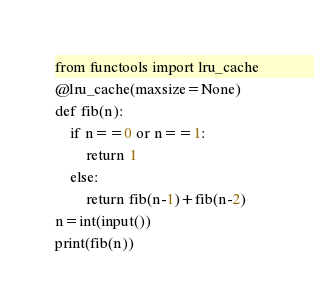<code> <loc_0><loc_0><loc_500><loc_500><_Python_>from functools import lru_cache
@lru_cache(maxsize=None)
def fib(n):
    if n==0 or n==1:
        return 1
    else:
        return fib(n-1)+fib(n-2)
n=int(input())
print(fib(n))
</code> 